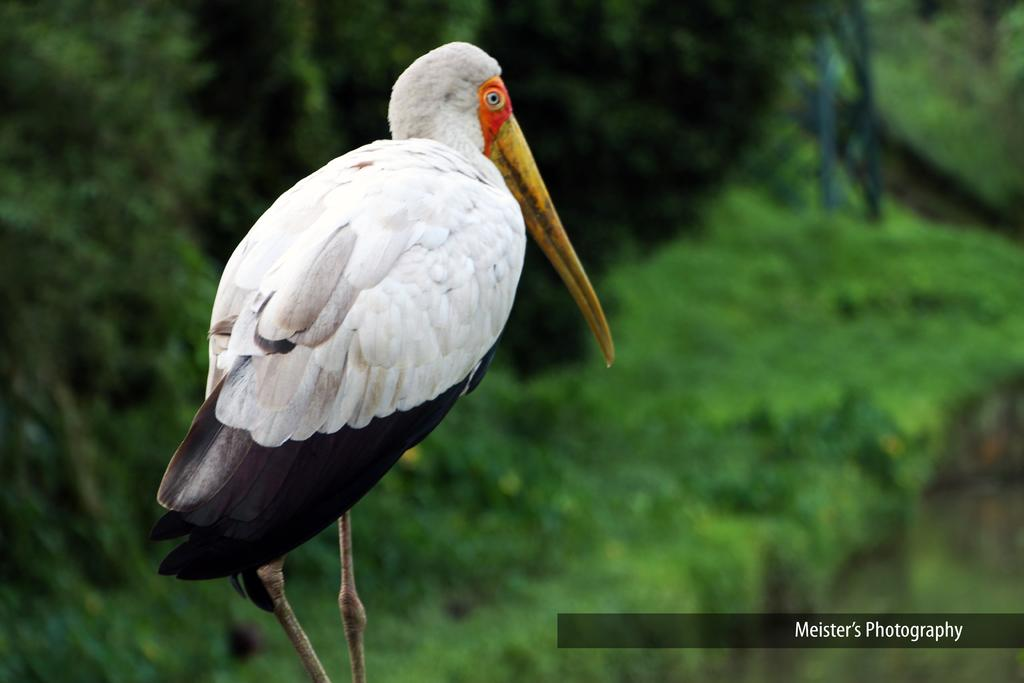What type of animal is in the image? There is a bird in the image. Can you describe the bird's appearance? The bird has white, black, yellow, and orange colors. Is there any text or marking in the image? Yes, there is a watermark at the right bottom of the image. How would you describe the background of the image? The background of the image has a greenish blurred appearance. What type of robin is defending its territory in the image? There is no robin present in the image, and no territory is being defended. What type of pail is visible in the image? There is no pail present in the image. 